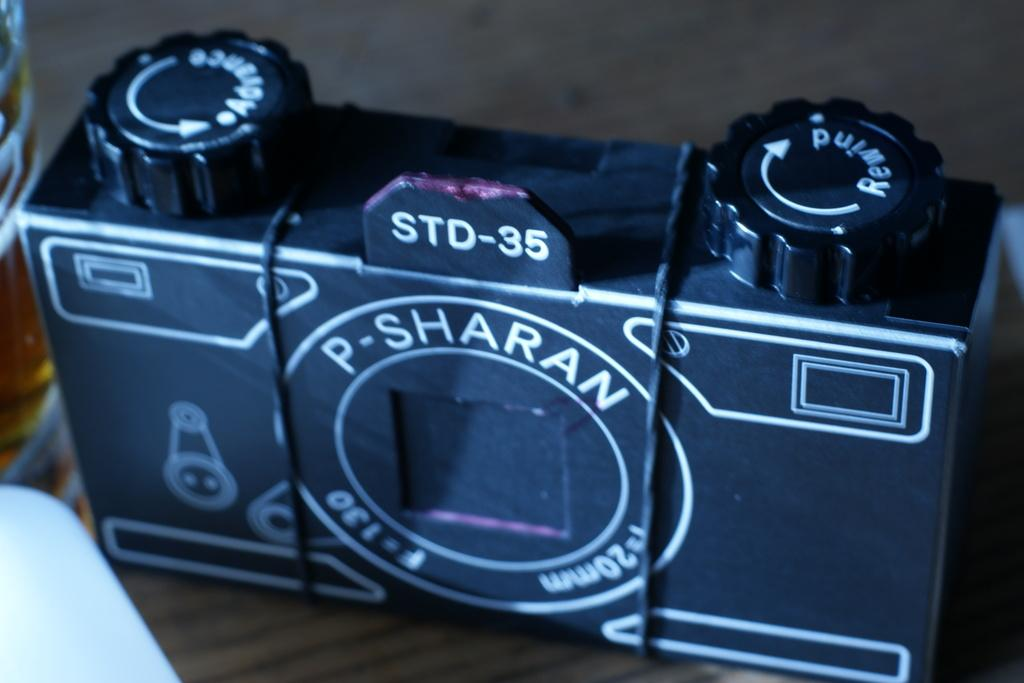<image>
Relay a brief, clear account of the picture shown. P. Sharan Camera that says on the top STD-35. 